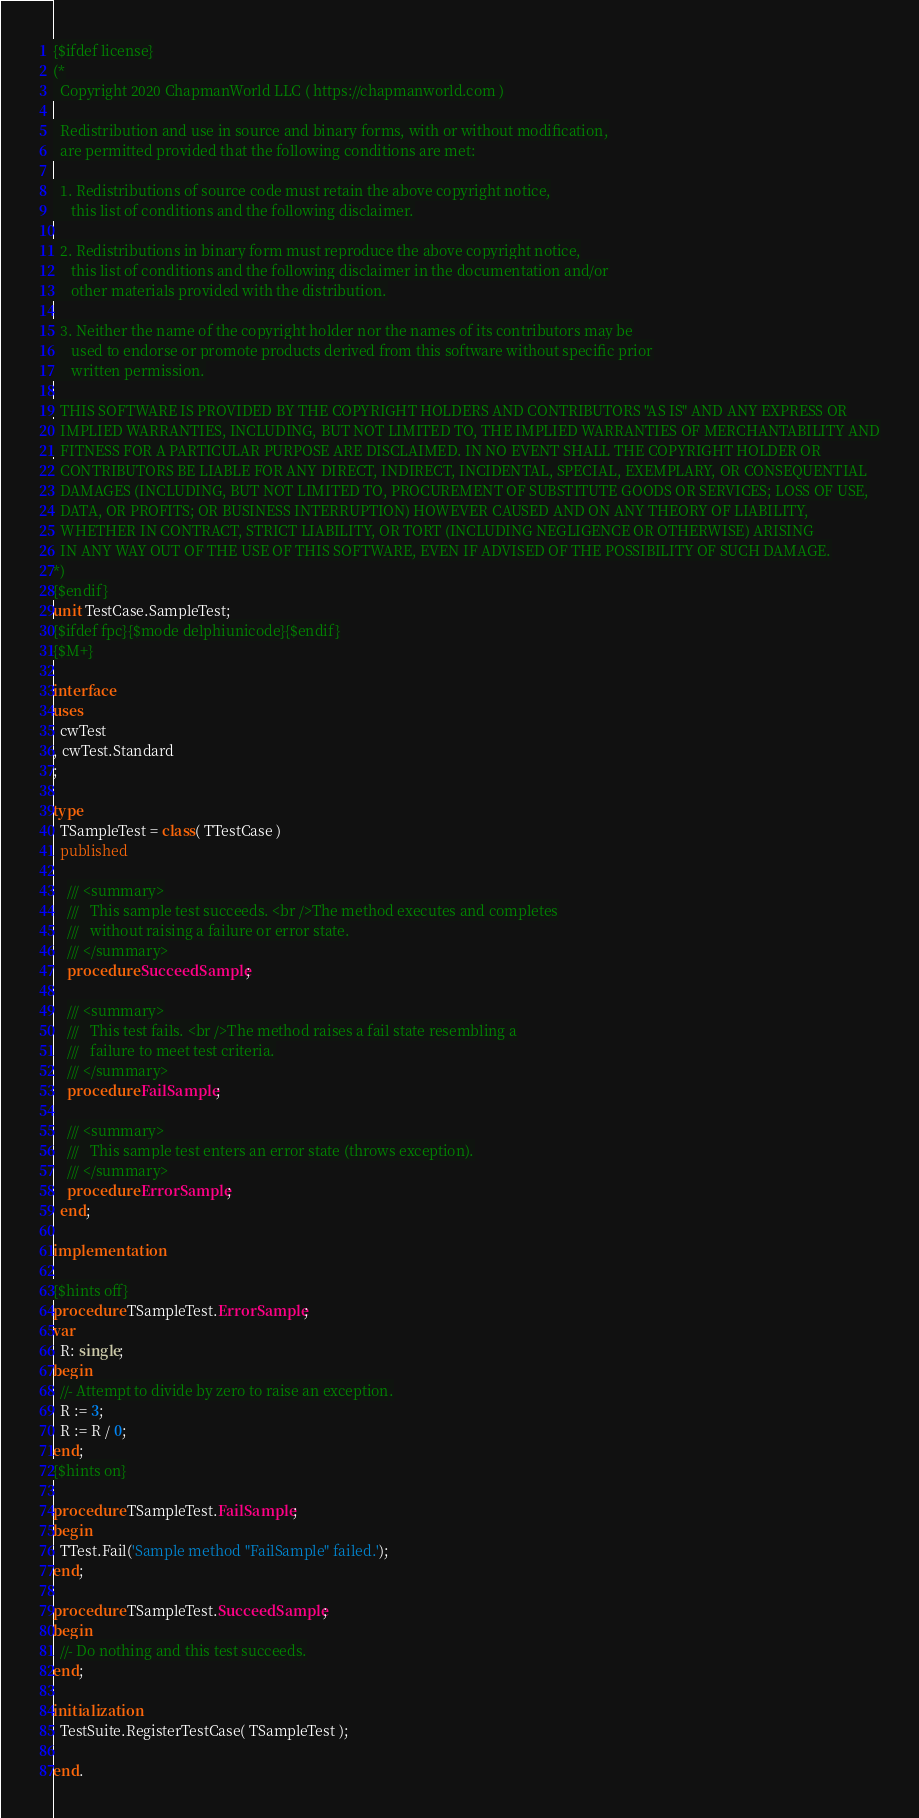<code> <loc_0><loc_0><loc_500><loc_500><_Pascal_>{$ifdef license}
(*
  Copyright 2020 ChapmanWorld LLC ( https://chapmanworld.com )

  Redistribution and use in source and binary forms, with or without modification,
  are permitted provided that the following conditions are met:

  1. Redistributions of source code must retain the above copyright notice,
     this list of conditions and the following disclaimer.

  2. Redistributions in binary form must reproduce the above copyright notice,
     this list of conditions and the following disclaimer in the documentation and/or
     other materials provided with the distribution.

  3. Neither the name of the copyright holder nor the names of its contributors may be
     used to endorse or promote products derived from this software without specific prior
     written permission.

  THIS SOFTWARE IS PROVIDED BY THE COPYRIGHT HOLDERS AND CONTRIBUTORS "AS IS" AND ANY EXPRESS OR
  IMPLIED WARRANTIES, INCLUDING, BUT NOT LIMITED TO, THE IMPLIED WARRANTIES OF MERCHANTABILITY AND
  FITNESS FOR A PARTICULAR PURPOSE ARE DISCLAIMED. IN NO EVENT SHALL THE COPYRIGHT HOLDER OR
  CONTRIBUTORS BE LIABLE FOR ANY DIRECT, INDIRECT, INCIDENTAL, SPECIAL, EXEMPLARY, OR CONSEQUENTIAL
  DAMAGES (INCLUDING, BUT NOT LIMITED TO, PROCUREMENT OF SUBSTITUTE GOODS OR SERVICES; LOSS OF USE,
  DATA, OR PROFITS; OR BUSINESS INTERRUPTION) HOWEVER CAUSED AND ON ANY THEORY OF LIABILITY,
  WHETHER IN CONTRACT, STRICT LIABILITY, OR TORT (INCLUDING NEGLIGENCE OR OTHERWISE) ARISING
  IN ANY WAY OUT OF THE USE OF THIS SOFTWARE, EVEN IF ADVISED OF THE POSSIBILITY OF SUCH DAMAGE.
*)
{$endif}
unit TestCase.SampleTest;
{$ifdef fpc}{$mode delphiunicode}{$endif}
{$M+}

interface
uses
  cwTest
, cwTest.Standard
;

type
  TSampleTest = class( TTestCase )
  published

    /// <summary>
    ///   This sample test succeeds. <br />The method executes and completes
    ///   without raising a failure or error state.
    /// </summary>
    procedure SucceedSample;

    /// <summary>
    ///   This test fails. <br />The method raises a fail state resembling a
    ///   failure to meet test criteria.
    /// </summary>
    procedure FailSample;

    /// <summary>
    ///   This sample test enters an error state (throws exception).
    /// </summary>
    procedure ErrorSample;
  end;

implementation

{$hints off}
procedure TSampleTest.ErrorSample;
var
  R: single;
begin
  //- Attempt to divide by zero to raise an exception.
  R := 3;
  R := R / 0;
end;
{$hints on}

procedure TSampleTest.FailSample;
begin
  TTest.Fail('Sample method "FailSample" failed.');
end;

procedure TSampleTest.SucceedSample;
begin
  //- Do nothing and this test succeeds.
end;

initialization
  TestSuite.RegisterTestCase( TSampleTest );

end.
</code> 